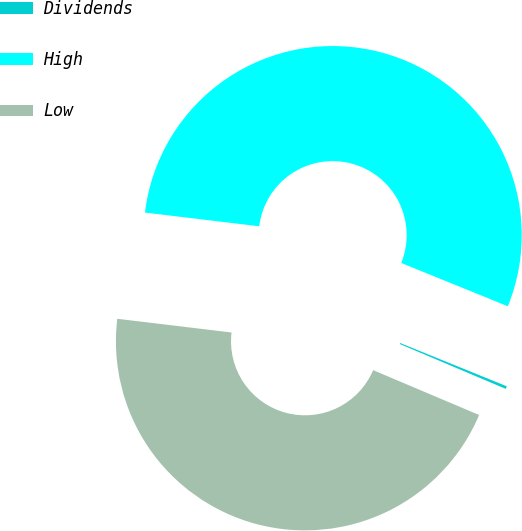Convert chart. <chart><loc_0><loc_0><loc_500><loc_500><pie_chart><fcel>Dividends<fcel>High<fcel>Low<nl><fcel>0.23%<fcel>54.24%<fcel>45.53%<nl></chart> 